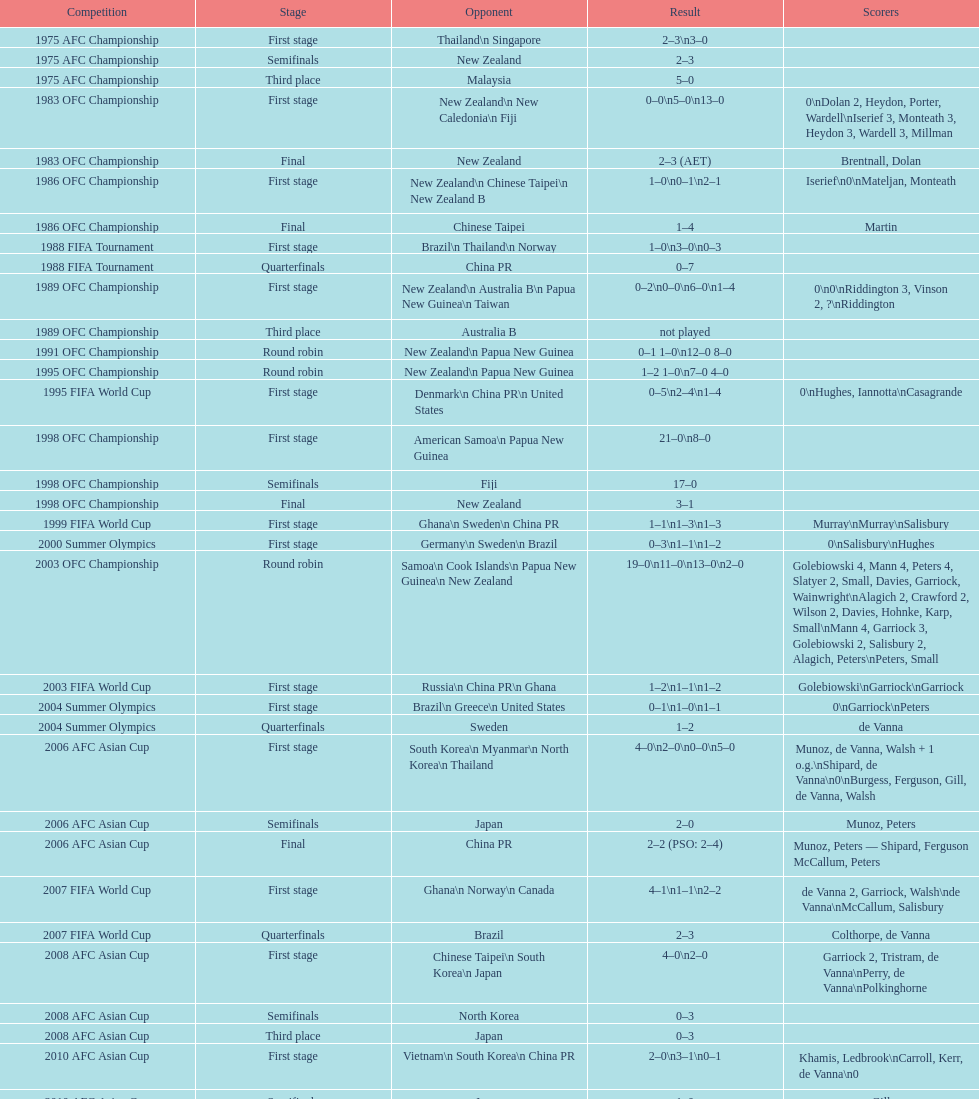Who scored better in the 1995 fifa world cup denmark or the united states? United States. 